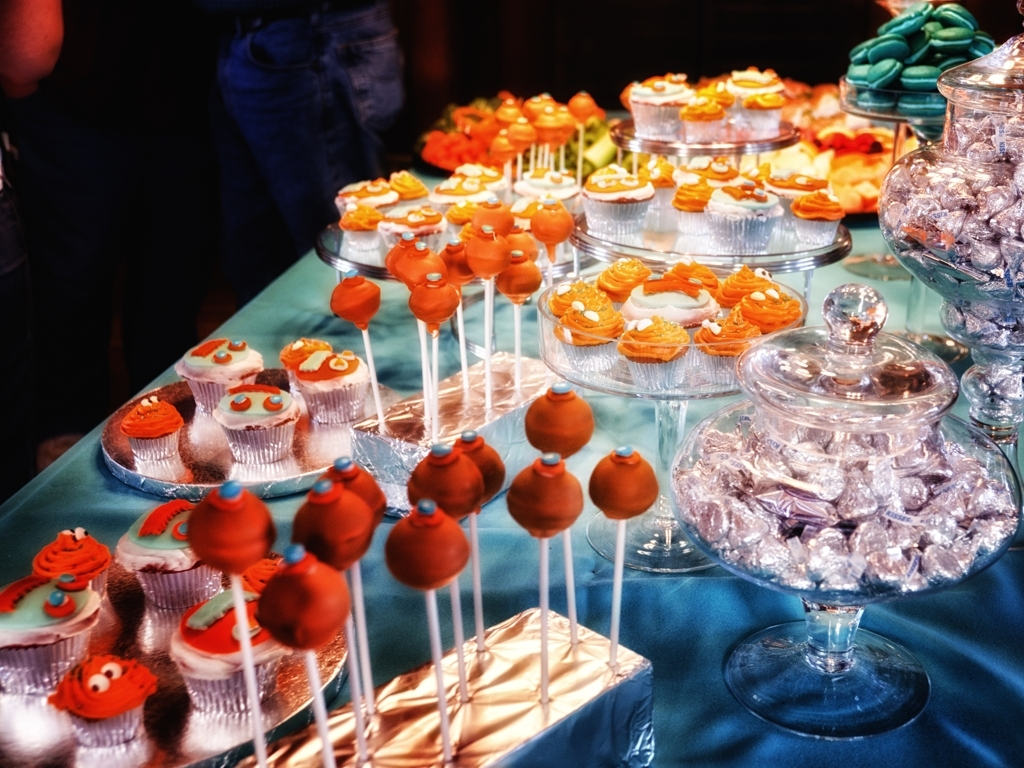Can you describe the different types of treats seen in this image? certainly! The image features a variety of sweets, including frosted cupcakes adorned with orange toppings and decorative elements. There are cake pops coated in a shiny glaze poised on sticks for easy enjoyment. Also visible are wrapped candies, likely chocolates, adding to the assortment of delectable goodies. 